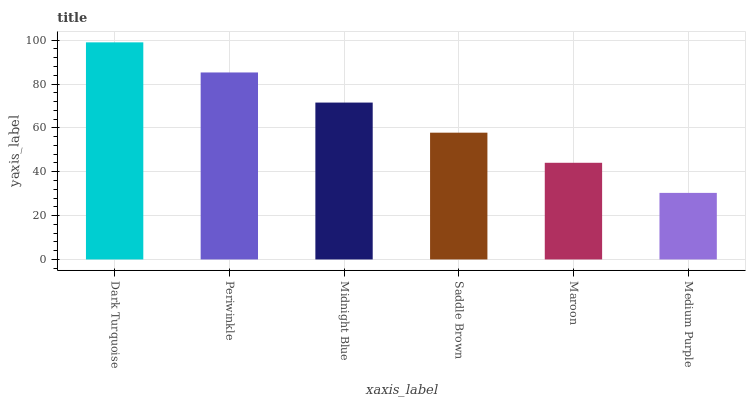Is Medium Purple the minimum?
Answer yes or no. Yes. Is Dark Turquoise the maximum?
Answer yes or no. Yes. Is Periwinkle the minimum?
Answer yes or no. No. Is Periwinkle the maximum?
Answer yes or no. No. Is Dark Turquoise greater than Periwinkle?
Answer yes or no. Yes. Is Periwinkle less than Dark Turquoise?
Answer yes or no. Yes. Is Periwinkle greater than Dark Turquoise?
Answer yes or no. No. Is Dark Turquoise less than Periwinkle?
Answer yes or no. No. Is Midnight Blue the high median?
Answer yes or no. Yes. Is Saddle Brown the low median?
Answer yes or no. Yes. Is Saddle Brown the high median?
Answer yes or no. No. Is Medium Purple the low median?
Answer yes or no. No. 